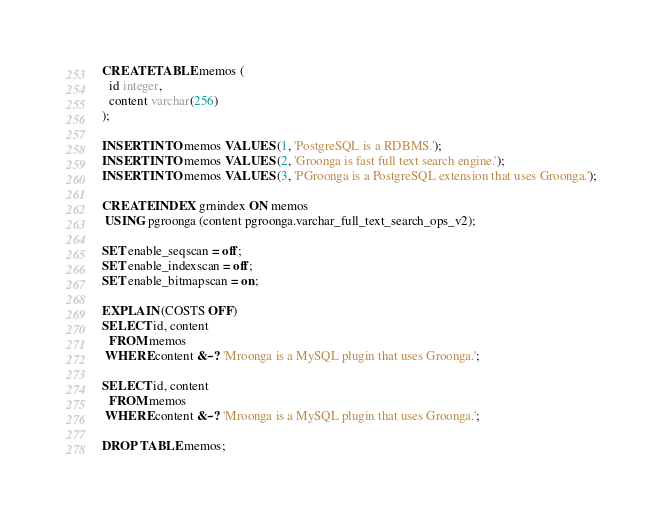Convert code to text. <code><loc_0><loc_0><loc_500><loc_500><_SQL_>CREATE TABLE memos (
  id integer,
  content varchar(256)
);

INSERT INTO memos VALUES (1, 'PostgreSQL is a RDBMS.');
INSERT INTO memos VALUES (2, 'Groonga is fast full text search engine.');
INSERT INTO memos VALUES (3, 'PGroonga is a PostgreSQL extension that uses Groonga.');

CREATE INDEX grnindex ON memos
 USING pgroonga (content pgroonga.varchar_full_text_search_ops_v2);

SET enable_seqscan = off;
SET enable_indexscan = off;
SET enable_bitmapscan = on;

EXPLAIN (COSTS OFF)
SELECT id, content
  FROM memos
 WHERE content &~? 'Mroonga is a MySQL plugin that uses Groonga.';

SELECT id, content
  FROM memos
 WHERE content &~? 'Mroonga is a MySQL plugin that uses Groonga.';

DROP TABLE memos;
</code> 